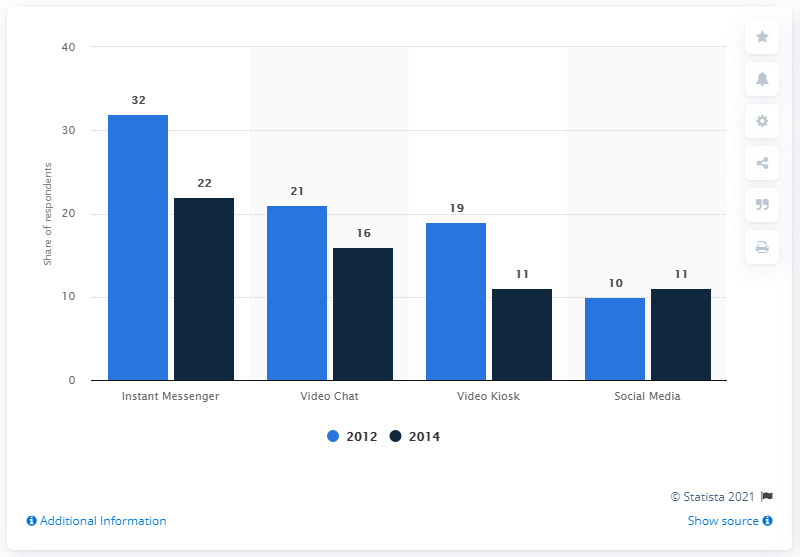Outline some significant characteristics in this image. The willingness to communicate through instant messaging significantly decreased in 2014, according to a study conducted by researchers. In 2014, 22% of customers were willing to communicate with the company through instant messaging. 